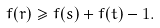Convert formula to latex. <formula><loc_0><loc_0><loc_500><loc_500>f ( { r } ) \geq f ( { s } ) + f ( { t } ) - 1 .</formula> 